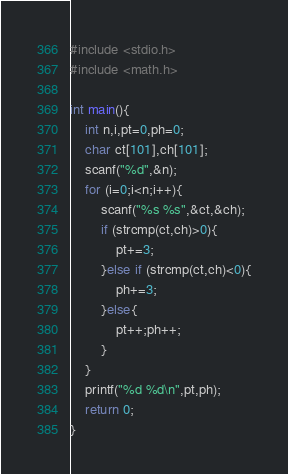Convert code to text. <code><loc_0><loc_0><loc_500><loc_500><_C_>#include <stdio.h>
#include <math.h>

int main(){
	int n,i,pt=0,ph=0;
	char ct[101],ch[101];
	scanf("%d",&n);
	for (i=0;i<n;i++){
		scanf("%s %s",&ct,&ch);
		if (strcmp(ct,ch)>0){
			pt+=3;
		}else if (strcmp(ct,ch)<0){
			ph+=3;
		}else{
			pt++;ph++;
		}
	}
	printf("%d %d\n",pt,ph);
	return 0;
}	</code> 